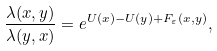Convert formula to latex. <formula><loc_0><loc_0><loc_500><loc_500>\frac { \lambda ( x , y ) } { \lambda ( y , x ) } = e ^ { U ( x ) - U ( y ) + F _ { \varepsilon } ( x , y ) } ,</formula> 